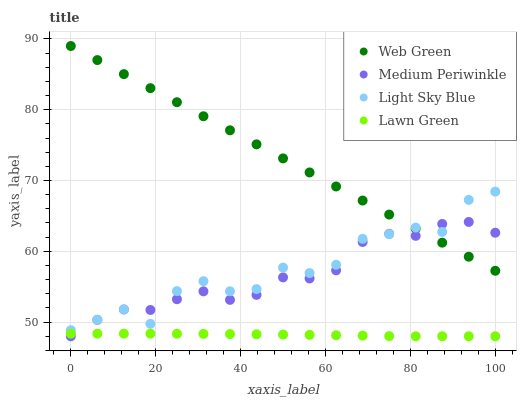Does Lawn Green have the minimum area under the curve?
Answer yes or no. Yes. Does Web Green have the maximum area under the curve?
Answer yes or no. Yes. Does Light Sky Blue have the minimum area under the curve?
Answer yes or no. No. Does Light Sky Blue have the maximum area under the curve?
Answer yes or no. No. Is Web Green the smoothest?
Answer yes or no. Yes. Is Light Sky Blue the roughest?
Answer yes or no. Yes. Is Medium Periwinkle the smoothest?
Answer yes or no. No. Is Medium Periwinkle the roughest?
Answer yes or no. No. Does Lawn Green have the lowest value?
Answer yes or no. Yes. Does Light Sky Blue have the lowest value?
Answer yes or no. No. Does Web Green have the highest value?
Answer yes or no. Yes. Does Light Sky Blue have the highest value?
Answer yes or no. No. Is Lawn Green less than Light Sky Blue?
Answer yes or no. Yes. Is Light Sky Blue greater than Lawn Green?
Answer yes or no. Yes. Does Web Green intersect Medium Periwinkle?
Answer yes or no. Yes. Is Web Green less than Medium Periwinkle?
Answer yes or no. No. Is Web Green greater than Medium Periwinkle?
Answer yes or no. No. Does Lawn Green intersect Light Sky Blue?
Answer yes or no. No. 